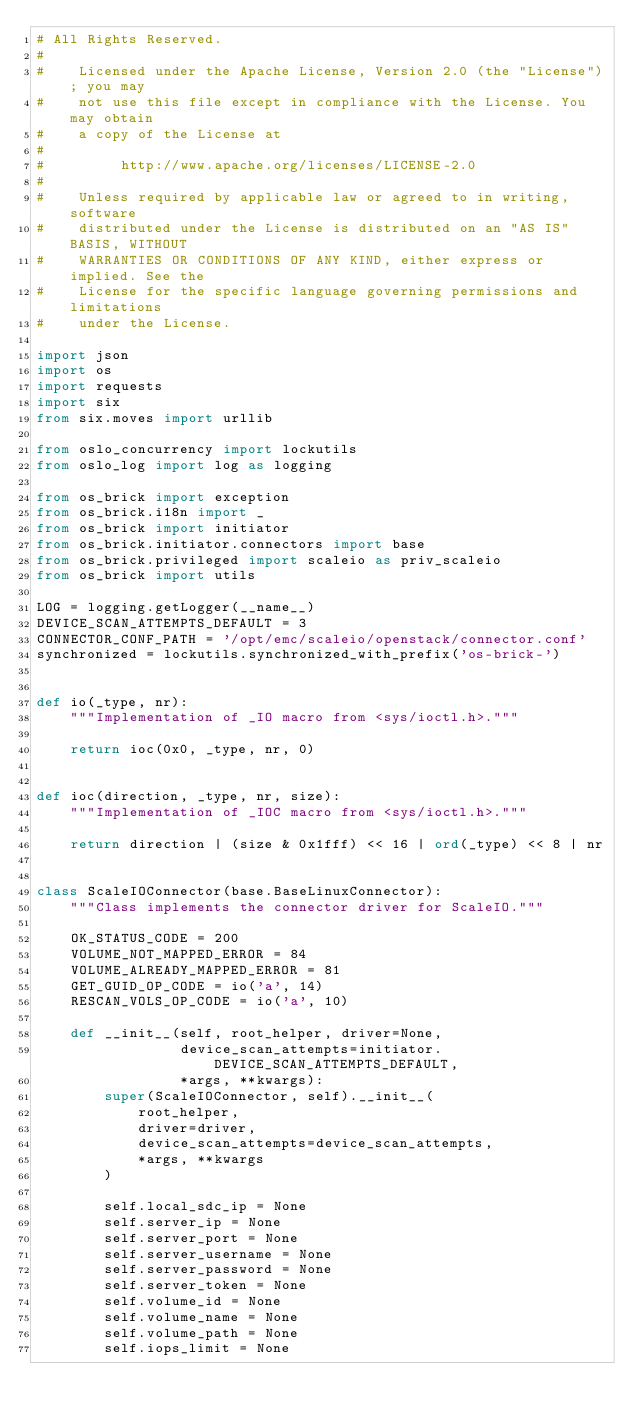Convert code to text. <code><loc_0><loc_0><loc_500><loc_500><_Python_># All Rights Reserved.
#
#    Licensed under the Apache License, Version 2.0 (the "License"); you may
#    not use this file except in compliance with the License. You may obtain
#    a copy of the License at
#
#         http://www.apache.org/licenses/LICENSE-2.0
#
#    Unless required by applicable law or agreed to in writing, software
#    distributed under the License is distributed on an "AS IS" BASIS, WITHOUT
#    WARRANTIES OR CONDITIONS OF ANY KIND, either express or implied. See the
#    License for the specific language governing permissions and limitations
#    under the License.

import json
import os
import requests
import six
from six.moves import urllib

from oslo_concurrency import lockutils
from oslo_log import log as logging

from os_brick import exception
from os_brick.i18n import _
from os_brick import initiator
from os_brick.initiator.connectors import base
from os_brick.privileged import scaleio as priv_scaleio
from os_brick import utils

LOG = logging.getLogger(__name__)
DEVICE_SCAN_ATTEMPTS_DEFAULT = 3
CONNECTOR_CONF_PATH = '/opt/emc/scaleio/openstack/connector.conf'
synchronized = lockutils.synchronized_with_prefix('os-brick-')


def io(_type, nr):
    """Implementation of _IO macro from <sys/ioctl.h>."""

    return ioc(0x0, _type, nr, 0)


def ioc(direction, _type, nr, size):
    """Implementation of _IOC macro from <sys/ioctl.h>."""

    return direction | (size & 0x1fff) << 16 | ord(_type) << 8 | nr


class ScaleIOConnector(base.BaseLinuxConnector):
    """Class implements the connector driver for ScaleIO."""

    OK_STATUS_CODE = 200
    VOLUME_NOT_MAPPED_ERROR = 84
    VOLUME_ALREADY_MAPPED_ERROR = 81
    GET_GUID_OP_CODE = io('a', 14)
    RESCAN_VOLS_OP_CODE = io('a', 10)

    def __init__(self, root_helper, driver=None,
                 device_scan_attempts=initiator.DEVICE_SCAN_ATTEMPTS_DEFAULT,
                 *args, **kwargs):
        super(ScaleIOConnector, self).__init__(
            root_helper,
            driver=driver,
            device_scan_attempts=device_scan_attempts,
            *args, **kwargs
        )

        self.local_sdc_ip = None
        self.server_ip = None
        self.server_port = None
        self.server_username = None
        self.server_password = None
        self.server_token = None
        self.volume_id = None
        self.volume_name = None
        self.volume_path = None
        self.iops_limit = None</code> 